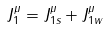<formula> <loc_0><loc_0><loc_500><loc_500>J _ { 1 } ^ { \mu } = J _ { 1 s } ^ { \mu } + J _ { 1 w } ^ { \mu }</formula> 